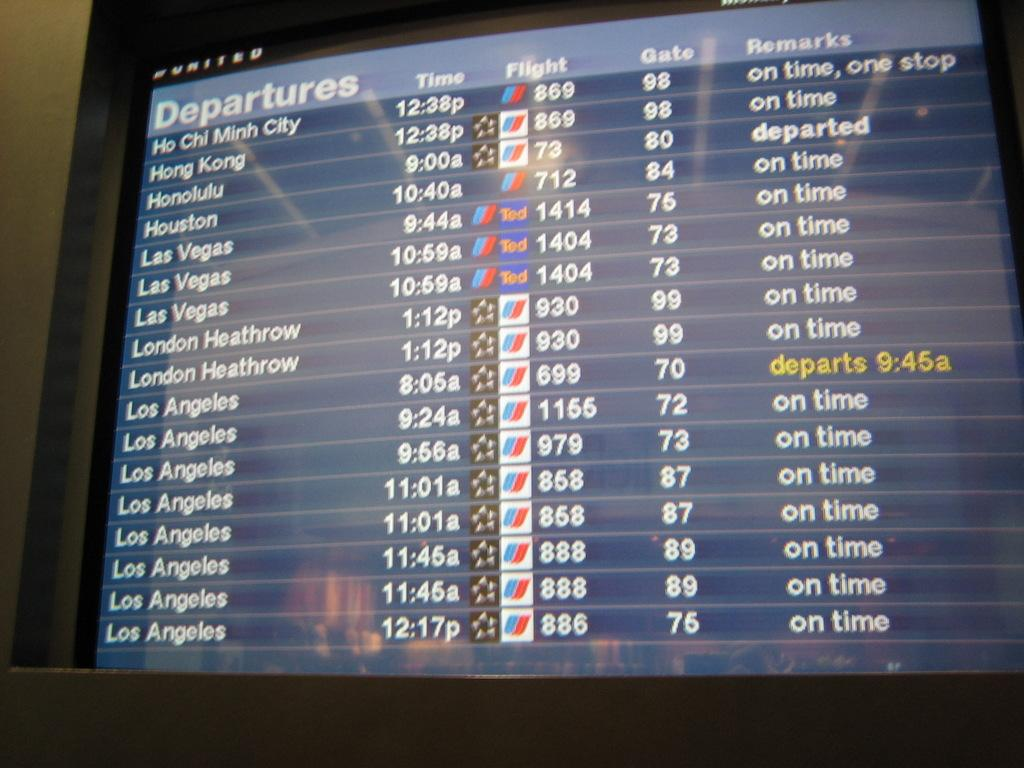<image>
Describe the image concisely. A screen at an airport showing depature times and gate locations. 